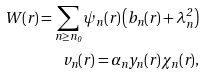Convert formula to latex. <formula><loc_0><loc_0><loc_500><loc_500>W ( r ) = \sum _ { n \geq n _ { 0 } } \psi _ { n } ( r ) \left ( b _ { n } ( r ) + \lambda _ { n } ^ { 2 } \right ) \\ v _ { n } ( r ) = \alpha _ { n } y _ { n } ( r ) \chi _ { n } ( r ) ,</formula> 